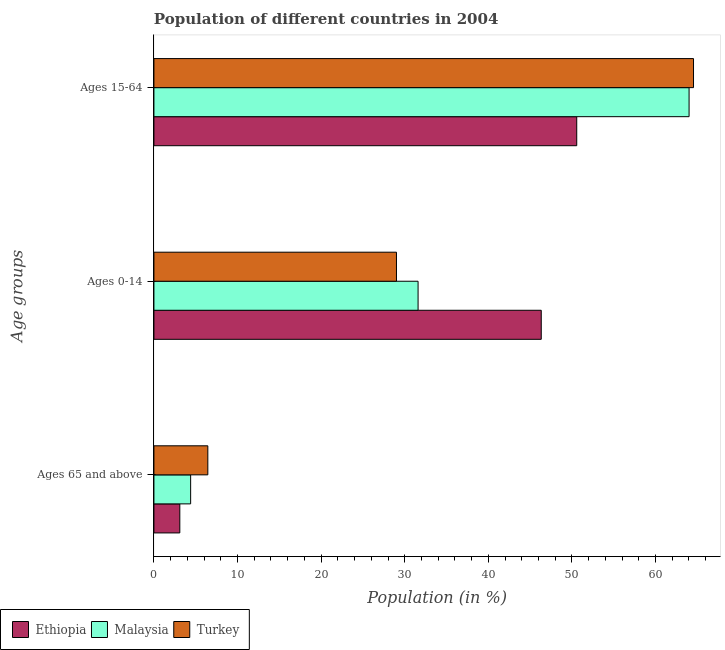How many groups of bars are there?
Provide a short and direct response. 3. How many bars are there on the 2nd tick from the bottom?
Your answer should be compact. 3. What is the label of the 1st group of bars from the top?
Make the answer very short. Ages 15-64. What is the percentage of population within the age-group of 65 and above in Turkey?
Offer a terse response. 6.45. Across all countries, what is the maximum percentage of population within the age-group 15-64?
Offer a very short reply. 64.54. Across all countries, what is the minimum percentage of population within the age-group 15-64?
Ensure brevity in your answer.  50.57. In which country was the percentage of population within the age-group 15-64 maximum?
Make the answer very short. Turkey. In which country was the percentage of population within the age-group of 65 and above minimum?
Give a very brief answer. Ethiopia. What is the total percentage of population within the age-group 15-64 in the graph?
Your answer should be very brief. 179.13. What is the difference between the percentage of population within the age-group 15-64 in Turkey and that in Ethiopia?
Make the answer very short. 13.97. What is the difference between the percentage of population within the age-group 0-14 in Malaysia and the percentage of population within the age-group 15-64 in Turkey?
Provide a succinct answer. -32.95. What is the average percentage of population within the age-group 0-14 per country?
Your response must be concise. 35.65. What is the difference between the percentage of population within the age-group 15-64 and percentage of population within the age-group 0-14 in Malaysia?
Ensure brevity in your answer.  32.42. In how many countries, is the percentage of population within the age-group 0-14 greater than 4 %?
Provide a succinct answer. 3. What is the ratio of the percentage of population within the age-group 0-14 in Malaysia to that in Ethiopia?
Keep it short and to the point. 0.68. Is the percentage of population within the age-group of 65 and above in Malaysia less than that in Ethiopia?
Offer a terse response. No. Is the difference between the percentage of population within the age-group 0-14 in Malaysia and Turkey greater than the difference between the percentage of population within the age-group 15-64 in Malaysia and Turkey?
Provide a succinct answer. Yes. What is the difference between the highest and the second highest percentage of population within the age-group 15-64?
Give a very brief answer. 0.53. What is the difference between the highest and the lowest percentage of population within the age-group of 65 and above?
Provide a short and direct response. 3.35. In how many countries, is the percentage of population within the age-group of 65 and above greater than the average percentage of population within the age-group of 65 and above taken over all countries?
Your answer should be very brief. 1. Is it the case that in every country, the sum of the percentage of population within the age-group of 65 and above and percentage of population within the age-group 0-14 is greater than the percentage of population within the age-group 15-64?
Keep it short and to the point. No. How many bars are there?
Offer a terse response. 9. Are all the bars in the graph horizontal?
Keep it short and to the point. Yes. How many countries are there in the graph?
Offer a terse response. 3. Does the graph contain grids?
Offer a terse response. No. Where does the legend appear in the graph?
Ensure brevity in your answer.  Bottom left. How many legend labels are there?
Your answer should be compact. 3. What is the title of the graph?
Offer a terse response. Population of different countries in 2004. What is the label or title of the X-axis?
Provide a succinct answer. Population (in %). What is the label or title of the Y-axis?
Provide a short and direct response. Age groups. What is the Population (in %) of Ethiopia in Ages 65 and above?
Provide a short and direct response. 3.1. What is the Population (in %) of Malaysia in Ages 65 and above?
Offer a very short reply. 4.39. What is the Population (in %) of Turkey in Ages 65 and above?
Your answer should be compact. 6.45. What is the Population (in %) of Ethiopia in Ages 0-14?
Your response must be concise. 46.33. What is the Population (in %) of Malaysia in Ages 0-14?
Your answer should be compact. 31.6. What is the Population (in %) in Turkey in Ages 0-14?
Make the answer very short. 29.01. What is the Population (in %) of Ethiopia in Ages 15-64?
Make the answer very short. 50.57. What is the Population (in %) in Malaysia in Ages 15-64?
Your response must be concise. 64.01. What is the Population (in %) of Turkey in Ages 15-64?
Offer a terse response. 64.54. Across all Age groups, what is the maximum Population (in %) of Ethiopia?
Give a very brief answer. 50.57. Across all Age groups, what is the maximum Population (in %) in Malaysia?
Provide a short and direct response. 64.01. Across all Age groups, what is the maximum Population (in %) in Turkey?
Your response must be concise. 64.54. Across all Age groups, what is the minimum Population (in %) of Ethiopia?
Offer a very short reply. 3.1. Across all Age groups, what is the minimum Population (in %) in Malaysia?
Your answer should be very brief. 4.39. Across all Age groups, what is the minimum Population (in %) in Turkey?
Your answer should be compact. 6.45. What is the total Population (in %) of Malaysia in the graph?
Keep it short and to the point. 100. What is the total Population (in %) in Turkey in the graph?
Offer a terse response. 100. What is the difference between the Population (in %) in Ethiopia in Ages 65 and above and that in Ages 0-14?
Keep it short and to the point. -43.23. What is the difference between the Population (in %) in Malaysia in Ages 65 and above and that in Ages 0-14?
Offer a very short reply. -27.2. What is the difference between the Population (in %) in Turkey in Ages 65 and above and that in Ages 0-14?
Provide a succinct answer. -22.56. What is the difference between the Population (in %) of Ethiopia in Ages 65 and above and that in Ages 15-64?
Offer a terse response. -47.48. What is the difference between the Population (in %) of Malaysia in Ages 65 and above and that in Ages 15-64?
Make the answer very short. -59.62. What is the difference between the Population (in %) in Turkey in Ages 65 and above and that in Ages 15-64?
Keep it short and to the point. -58.09. What is the difference between the Population (in %) in Ethiopia in Ages 0-14 and that in Ages 15-64?
Your answer should be compact. -4.24. What is the difference between the Population (in %) in Malaysia in Ages 0-14 and that in Ages 15-64?
Offer a very short reply. -32.42. What is the difference between the Population (in %) in Turkey in Ages 0-14 and that in Ages 15-64?
Provide a succinct answer. -35.53. What is the difference between the Population (in %) in Ethiopia in Ages 65 and above and the Population (in %) in Malaysia in Ages 0-14?
Offer a terse response. -28.5. What is the difference between the Population (in %) of Ethiopia in Ages 65 and above and the Population (in %) of Turkey in Ages 0-14?
Your answer should be very brief. -25.92. What is the difference between the Population (in %) of Malaysia in Ages 65 and above and the Population (in %) of Turkey in Ages 0-14?
Your answer should be very brief. -24.62. What is the difference between the Population (in %) of Ethiopia in Ages 65 and above and the Population (in %) of Malaysia in Ages 15-64?
Offer a terse response. -60.91. What is the difference between the Population (in %) in Ethiopia in Ages 65 and above and the Population (in %) in Turkey in Ages 15-64?
Your answer should be compact. -61.44. What is the difference between the Population (in %) of Malaysia in Ages 65 and above and the Population (in %) of Turkey in Ages 15-64?
Your answer should be very brief. -60.15. What is the difference between the Population (in %) of Ethiopia in Ages 0-14 and the Population (in %) of Malaysia in Ages 15-64?
Keep it short and to the point. -17.68. What is the difference between the Population (in %) in Ethiopia in Ages 0-14 and the Population (in %) in Turkey in Ages 15-64?
Your response must be concise. -18.21. What is the difference between the Population (in %) of Malaysia in Ages 0-14 and the Population (in %) of Turkey in Ages 15-64?
Offer a very short reply. -32.95. What is the average Population (in %) in Ethiopia per Age groups?
Ensure brevity in your answer.  33.33. What is the average Population (in %) of Malaysia per Age groups?
Offer a terse response. 33.33. What is the average Population (in %) of Turkey per Age groups?
Your response must be concise. 33.33. What is the difference between the Population (in %) in Ethiopia and Population (in %) in Malaysia in Ages 65 and above?
Ensure brevity in your answer.  -1.3. What is the difference between the Population (in %) of Ethiopia and Population (in %) of Turkey in Ages 65 and above?
Ensure brevity in your answer.  -3.35. What is the difference between the Population (in %) in Malaysia and Population (in %) in Turkey in Ages 65 and above?
Your answer should be very brief. -2.06. What is the difference between the Population (in %) of Ethiopia and Population (in %) of Malaysia in Ages 0-14?
Provide a short and direct response. 14.73. What is the difference between the Population (in %) of Ethiopia and Population (in %) of Turkey in Ages 0-14?
Provide a short and direct response. 17.32. What is the difference between the Population (in %) of Malaysia and Population (in %) of Turkey in Ages 0-14?
Keep it short and to the point. 2.58. What is the difference between the Population (in %) in Ethiopia and Population (in %) in Malaysia in Ages 15-64?
Offer a very short reply. -13.44. What is the difference between the Population (in %) in Ethiopia and Population (in %) in Turkey in Ages 15-64?
Provide a succinct answer. -13.97. What is the difference between the Population (in %) of Malaysia and Population (in %) of Turkey in Ages 15-64?
Make the answer very short. -0.53. What is the ratio of the Population (in %) of Ethiopia in Ages 65 and above to that in Ages 0-14?
Ensure brevity in your answer.  0.07. What is the ratio of the Population (in %) in Malaysia in Ages 65 and above to that in Ages 0-14?
Provide a succinct answer. 0.14. What is the ratio of the Population (in %) of Turkey in Ages 65 and above to that in Ages 0-14?
Make the answer very short. 0.22. What is the ratio of the Population (in %) of Ethiopia in Ages 65 and above to that in Ages 15-64?
Make the answer very short. 0.06. What is the ratio of the Population (in %) in Malaysia in Ages 65 and above to that in Ages 15-64?
Your response must be concise. 0.07. What is the ratio of the Population (in %) of Turkey in Ages 65 and above to that in Ages 15-64?
Your response must be concise. 0.1. What is the ratio of the Population (in %) of Ethiopia in Ages 0-14 to that in Ages 15-64?
Provide a short and direct response. 0.92. What is the ratio of the Population (in %) in Malaysia in Ages 0-14 to that in Ages 15-64?
Your answer should be very brief. 0.49. What is the ratio of the Population (in %) in Turkey in Ages 0-14 to that in Ages 15-64?
Your answer should be very brief. 0.45. What is the difference between the highest and the second highest Population (in %) in Ethiopia?
Provide a short and direct response. 4.24. What is the difference between the highest and the second highest Population (in %) of Malaysia?
Keep it short and to the point. 32.42. What is the difference between the highest and the second highest Population (in %) of Turkey?
Provide a short and direct response. 35.53. What is the difference between the highest and the lowest Population (in %) in Ethiopia?
Make the answer very short. 47.48. What is the difference between the highest and the lowest Population (in %) of Malaysia?
Keep it short and to the point. 59.62. What is the difference between the highest and the lowest Population (in %) in Turkey?
Offer a very short reply. 58.09. 